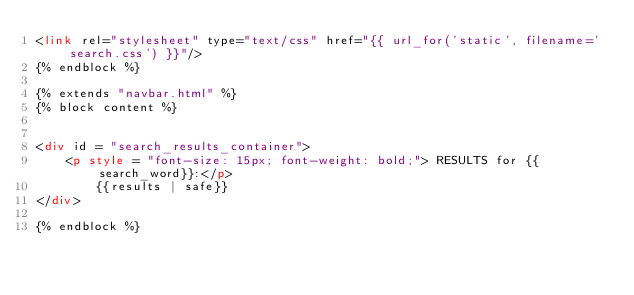<code> <loc_0><loc_0><loc_500><loc_500><_HTML_><link rel="stylesheet" type="text/css" href="{{ url_for('static', filename='search.css') }}"/>
{% endblock %}

{% extends "navbar.html" %}
{% block content %}


<div id = "search_results_container">
    <p style = "font-size: 15px; font-weight: bold;"> RESULTS for {{search_word}}:</p>
        {{results | safe}} 
</div>

{% endblock %}
</code> 